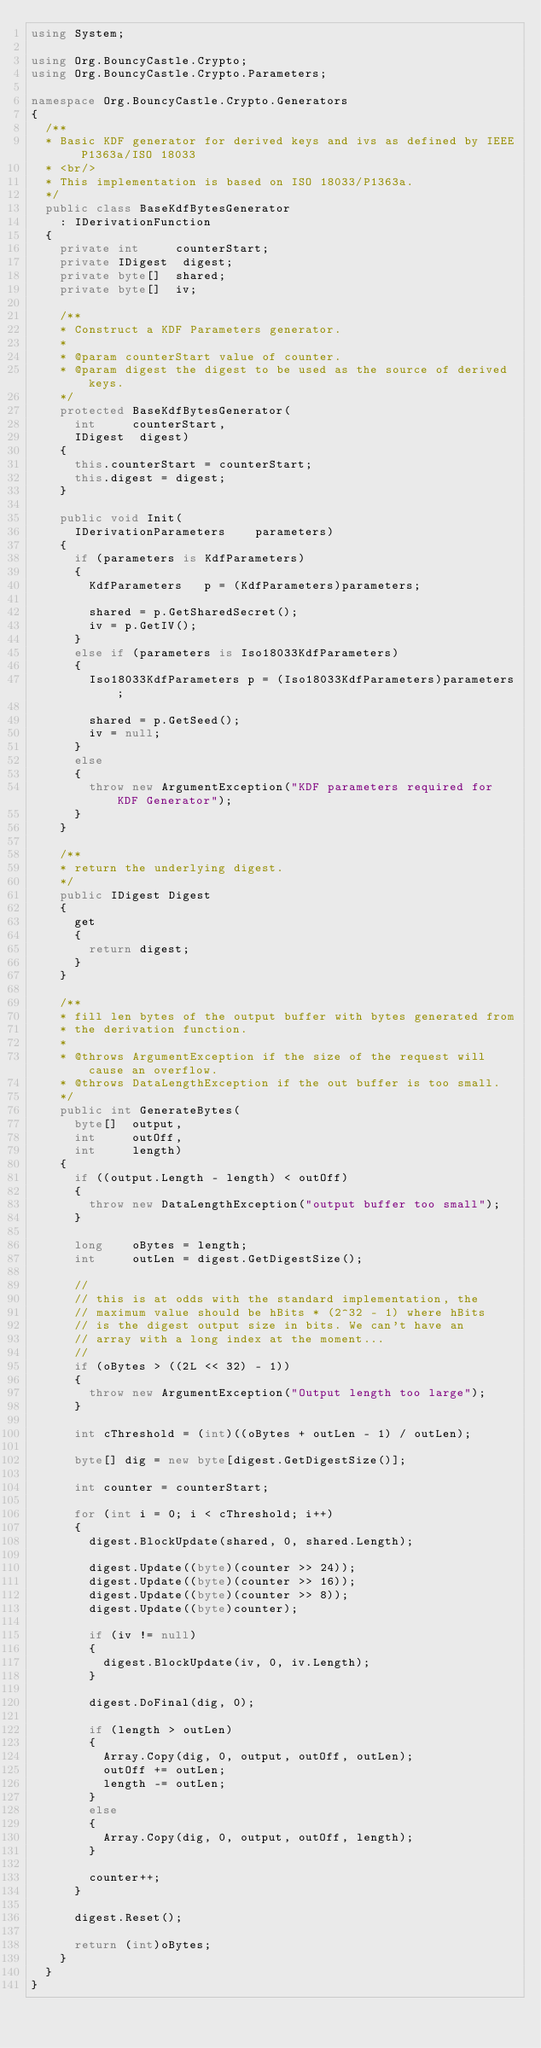<code> <loc_0><loc_0><loc_500><loc_500><_C#_>using System;

using Org.BouncyCastle.Crypto;
using Org.BouncyCastle.Crypto.Parameters;

namespace Org.BouncyCastle.Crypto.Generators
{
	/**
	* Basic KDF generator for derived keys and ivs as defined by IEEE P1363a/ISO 18033
	* <br/>
	* This implementation is based on ISO 18033/P1363a.
	*/
	public class BaseKdfBytesGenerator
		: IDerivationFunction
	{
		private int     counterStart;
		private IDigest  digest;
		private byte[]  shared;
		private byte[]  iv;

		/**
		* Construct a KDF Parameters generator.
		*
		* @param counterStart value of counter.
		* @param digest the digest to be used as the source of derived keys.
		*/
		protected BaseKdfBytesGenerator(
			int     counterStart,
			IDigest  digest)
		{
			this.counterStart = counterStart;
			this.digest = digest;
		}

		public void Init(
			IDerivationParameters    parameters)
		{
			if (parameters is KdfParameters)
			{
				KdfParameters   p = (KdfParameters)parameters;

				shared = p.GetSharedSecret();
				iv = p.GetIV();
			}
			else if (parameters is Iso18033KdfParameters)
			{
				Iso18033KdfParameters p = (Iso18033KdfParameters)parameters;

				shared = p.GetSeed();
				iv = null;
			}
			else
			{
				throw new ArgumentException("KDF parameters required for KDF Generator");
			}
		}

		/**
		* return the underlying digest.
		*/
		public IDigest Digest
		{
			get
			{
				return digest;
			}
		}

		/**
		* fill len bytes of the output buffer with bytes generated from
		* the derivation function.
		*
		* @throws ArgumentException if the size of the request will cause an overflow.
		* @throws DataLengthException if the out buffer is too small.
		*/
		public int GenerateBytes(
			byte[]  output,
			int     outOff,
			int     length)
		{
			if ((output.Length - length) < outOff)
			{
				throw new DataLengthException("output buffer too small");
			}

			long    oBytes = length;
			int     outLen = digest.GetDigestSize();

			//
			// this is at odds with the standard implementation, the
			// maximum value should be hBits * (2^32 - 1) where hBits
			// is the digest output size in bits. We can't have an
			// array with a long index at the moment...
			//
			if (oBytes > ((2L << 32) - 1))
			{
				throw new ArgumentException("Output length too large");
			}

			int cThreshold = (int)((oBytes + outLen - 1) / outLen);

			byte[] dig = new byte[digest.GetDigestSize()];

			int counter = counterStart;

			for (int i = 0; i < cThreshold; i++)
			{
				digest.BlockUpdate(shared, 0, shared.Length);

				digest.Update((byte)(counter >> 24));
				digest.Update((byte)(counter >> 16));
				digest.Update((byte)(counter >> 8));
				digest.Update((byte)counter);

				if (iv != null)
				{
					digest.BlockUpdate(iv, 0, iv.Length);
				}

				digest.DoFinal(dig, 0);

				if (length > outLen)
				{
					Array.Copy(dig, 0, output, outOff, outLen);
					outOff += outLen;
					length -= outLen;
				}
				else
				{
					Array.Copy(dig, 0, output, outOff, length);
				}

				counter++;
			}

			digest.Reset();

			return (int)oBytes;
		}
	}
}</code> 